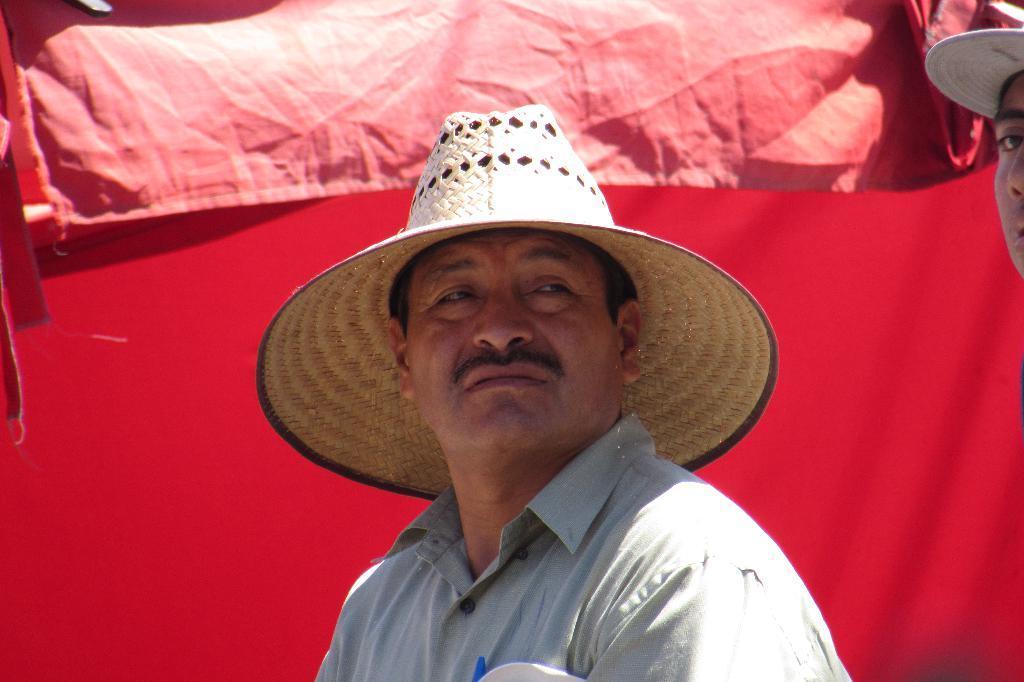Could you give a brief overview of what you see in this image? In this image there are two persons with hats, and there is red color background. 